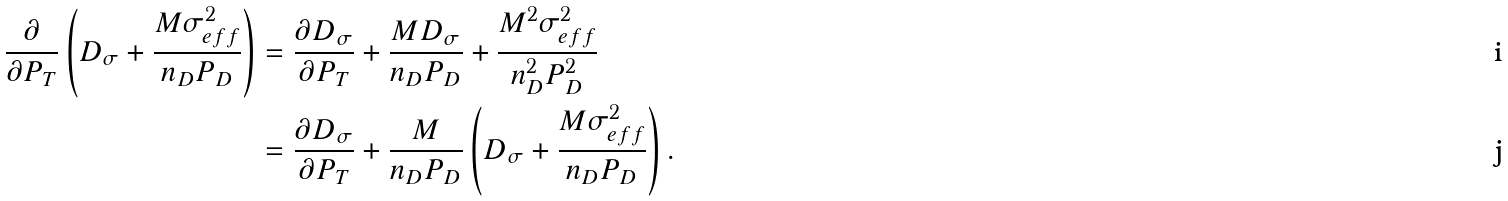<formula> <loc_0><loc_0><loc_500><loc_500>\frac { \partial } { \partial P _ { T } } \left ( D _ { \sigma } + \frac { M \sigma _ { e f f } ^ { 2 } } { n _ { D } P _ { D } } \right ) & = \frac { \partial D _ { \sigma } } { \partial P _ { T } } + \frac { M D _ { \sigma } } { n _ { D } P _ { D } } + \frac { M ^ { 2 } \sigma _ { e f f } ^ { 2 } } { n _ { D } ^ { 2 } P _ { D } ^ { 2 } } \\ & = \frac { \partial D _ { \sigma } } { \partial P _ { T } } + \frac { M } { n _ { D } P _ { D } } \left ( D _ { \sigma } + \frac { M \sigma _ { e f f } ^ { 2 } } { n _ { D } P _ { D } } \right ) .</formula> 